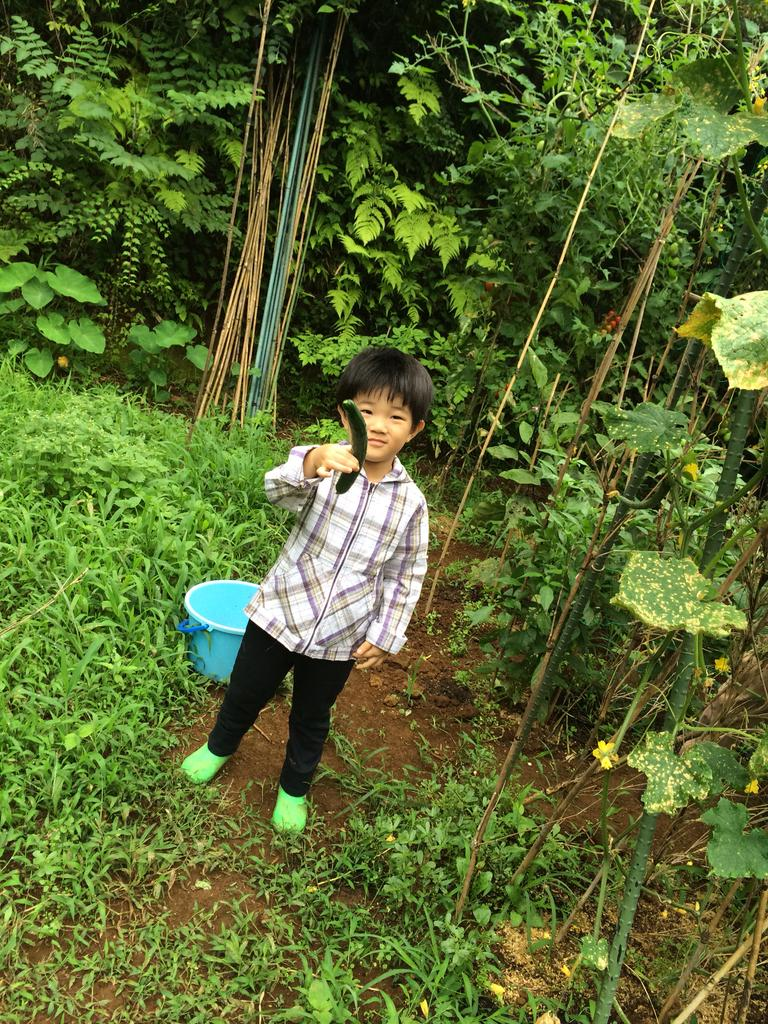Who is the main subject in the image? There is a boy in the image. What is the boy holding in the image? The boy is holding a cucumber. What can be seen on the ground in the image? There are plants and a blue color bucket on the ground. What is visible in the background of the image? There are trees and plants in the background of the image. What type of iron is being used to press the boy's clothes in the image? There is no iron present in the image; the boy is holding a cucumber and there are plants and a blue bucket on the ground. How many mittens can be seen on the boy's hands in the image? There are no mittens present in the image; the boy is holding a cucumber. 